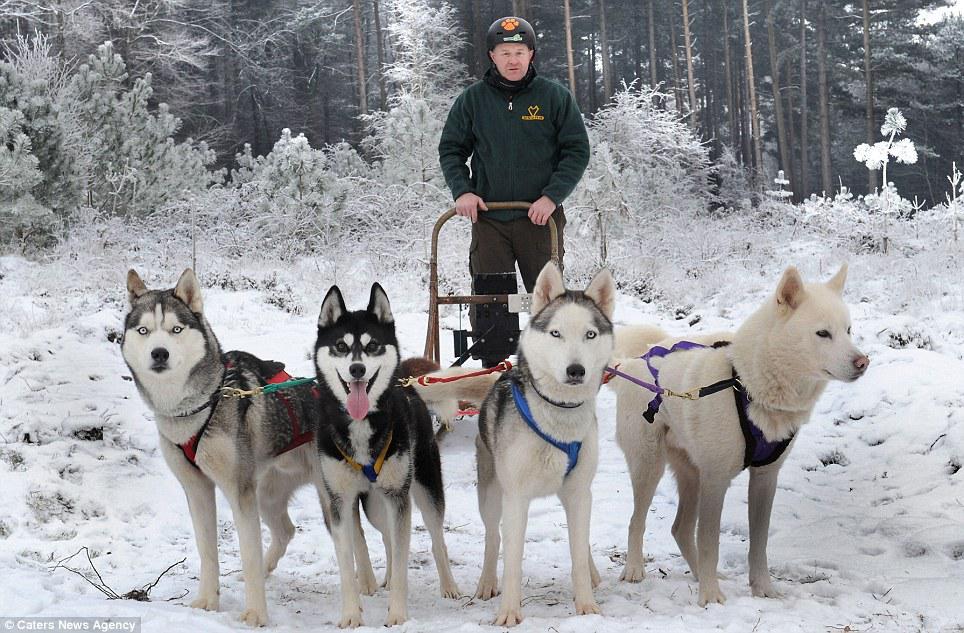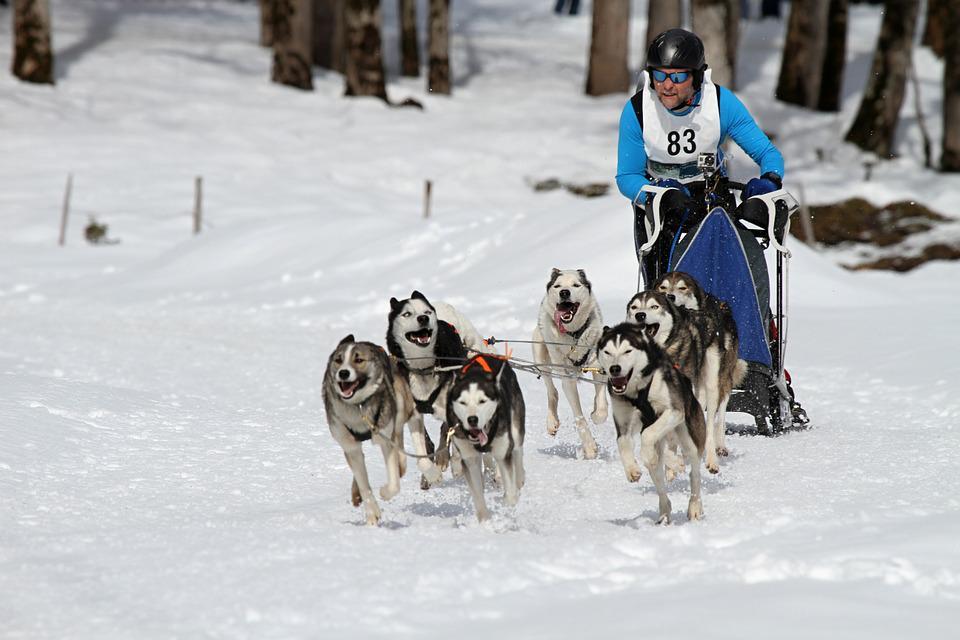The first image is the image on the left, the second image is the image on the right. Assess this claim about the two images: "One of the pictures shows more than one human being pulled by the dogs.". Correct or not? Answer yes or no. No. The first image is the image on the left, the second image is the image on the right. Assess this claim about the two images: "There are four dogs on the left image". Correct or not? Answer yes or no. Yes. The first image is the image on the left, the second image is the image on the right. Examine the images to the left and right. Is the description "A person wearing a blue jacket is driving the sled in the photo on the right.." accurate? Answer yes or no. Yes. 